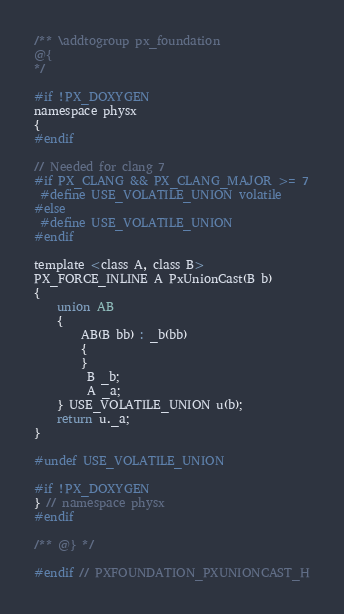<code> <loc_0><loc_0><loc_500><loc_500><_C_>
/** \addtogroup px_foundation
@{
*/

#if !PX_DOXYGEN
namespace physx
{
#endif

// Needed for clang 7
#if PX_CLANG && PX_CLANG_MAJOR >= 7
 #define USE_VOLATILE_UNION volatile 
#else
 #define USE_VOLATILE_UNION
#endif

template <class A, class B>
PX_FORCE_INLINE A PxUnionCast(B b)
{
	union AB
	{
		AB(B bb) : _b(bb)
		{
		}
		 B _b;
		 A _a;
	} USE_VOLATILE_UNION u(b);
	return u._a;
}

#undef USE_VOLATILE_UNION

#if !PX_DOXYGEN
} // namespace physx
#endif

/** @} */

#endif // PXFOUNDATION_PXUNIONCAST_H
</code> 